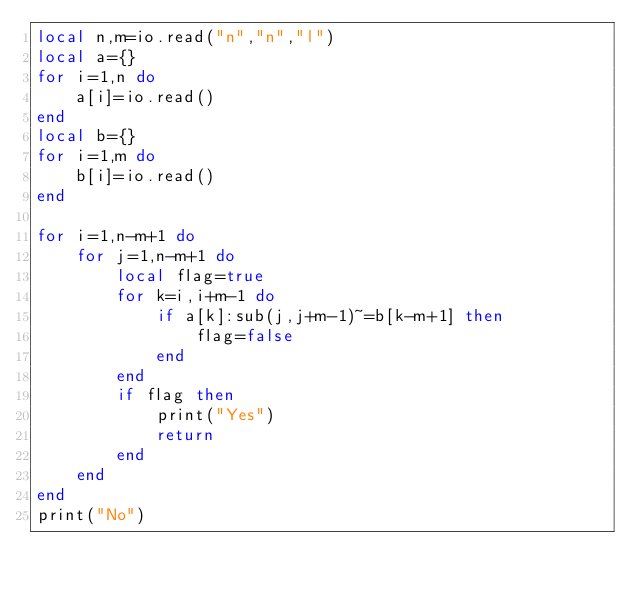<code> <loc_0><loc_0><loc_500><loc_500><_Lua_>local n,m=io.read("n","n","l")
local a={}
for i=1,n do
    a[i]=io.read()
end
local b={}
for i=1,m do
    b[i]=io.read()
end

for i=1,n-m+1 do
    for j=1,n-m+1 do
        local flag=true
        for k=i,i+m-1 do
            if a[k]:sub(j,j+m-1)~=b[k-m+1] then
                flag=false
            end
        end
        if flag then
            print("Yes")
            return
        end
    end
end
print("No")</code> 